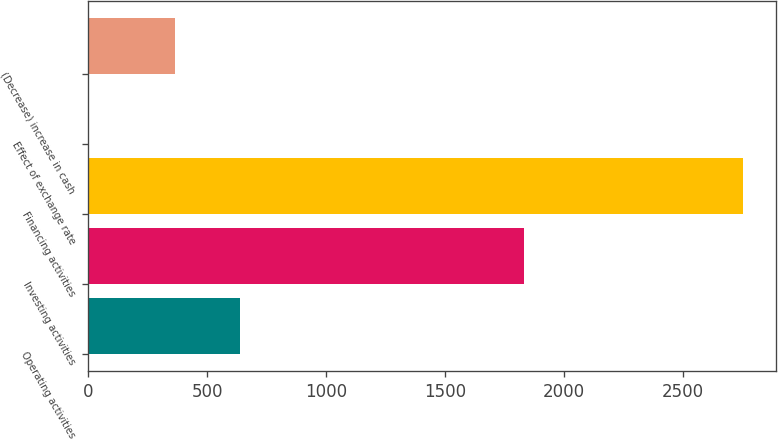Convert chart. <chart><loc_0><loc_0><loc_500><loc_500><bar_chart><fcel>Operating activities<fcel>Investing activities<fcel>Financing activities<fcel>Effect of exchange rate<fcel>(Decrease) increase in cash<nl><fcel>637<fcel>1830<fcel>2751<fcel>1<fcel>362<nl></chart> 